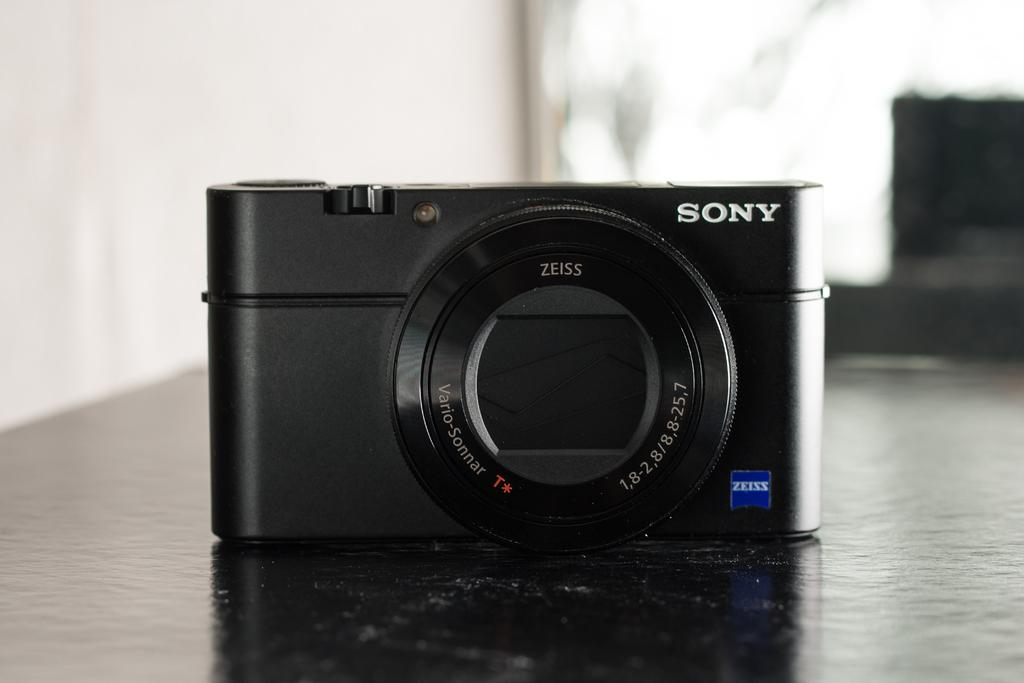<image>
Write a terse but informative summary of the picture. A Sony camera with a closed shutter is sitting on a table. 